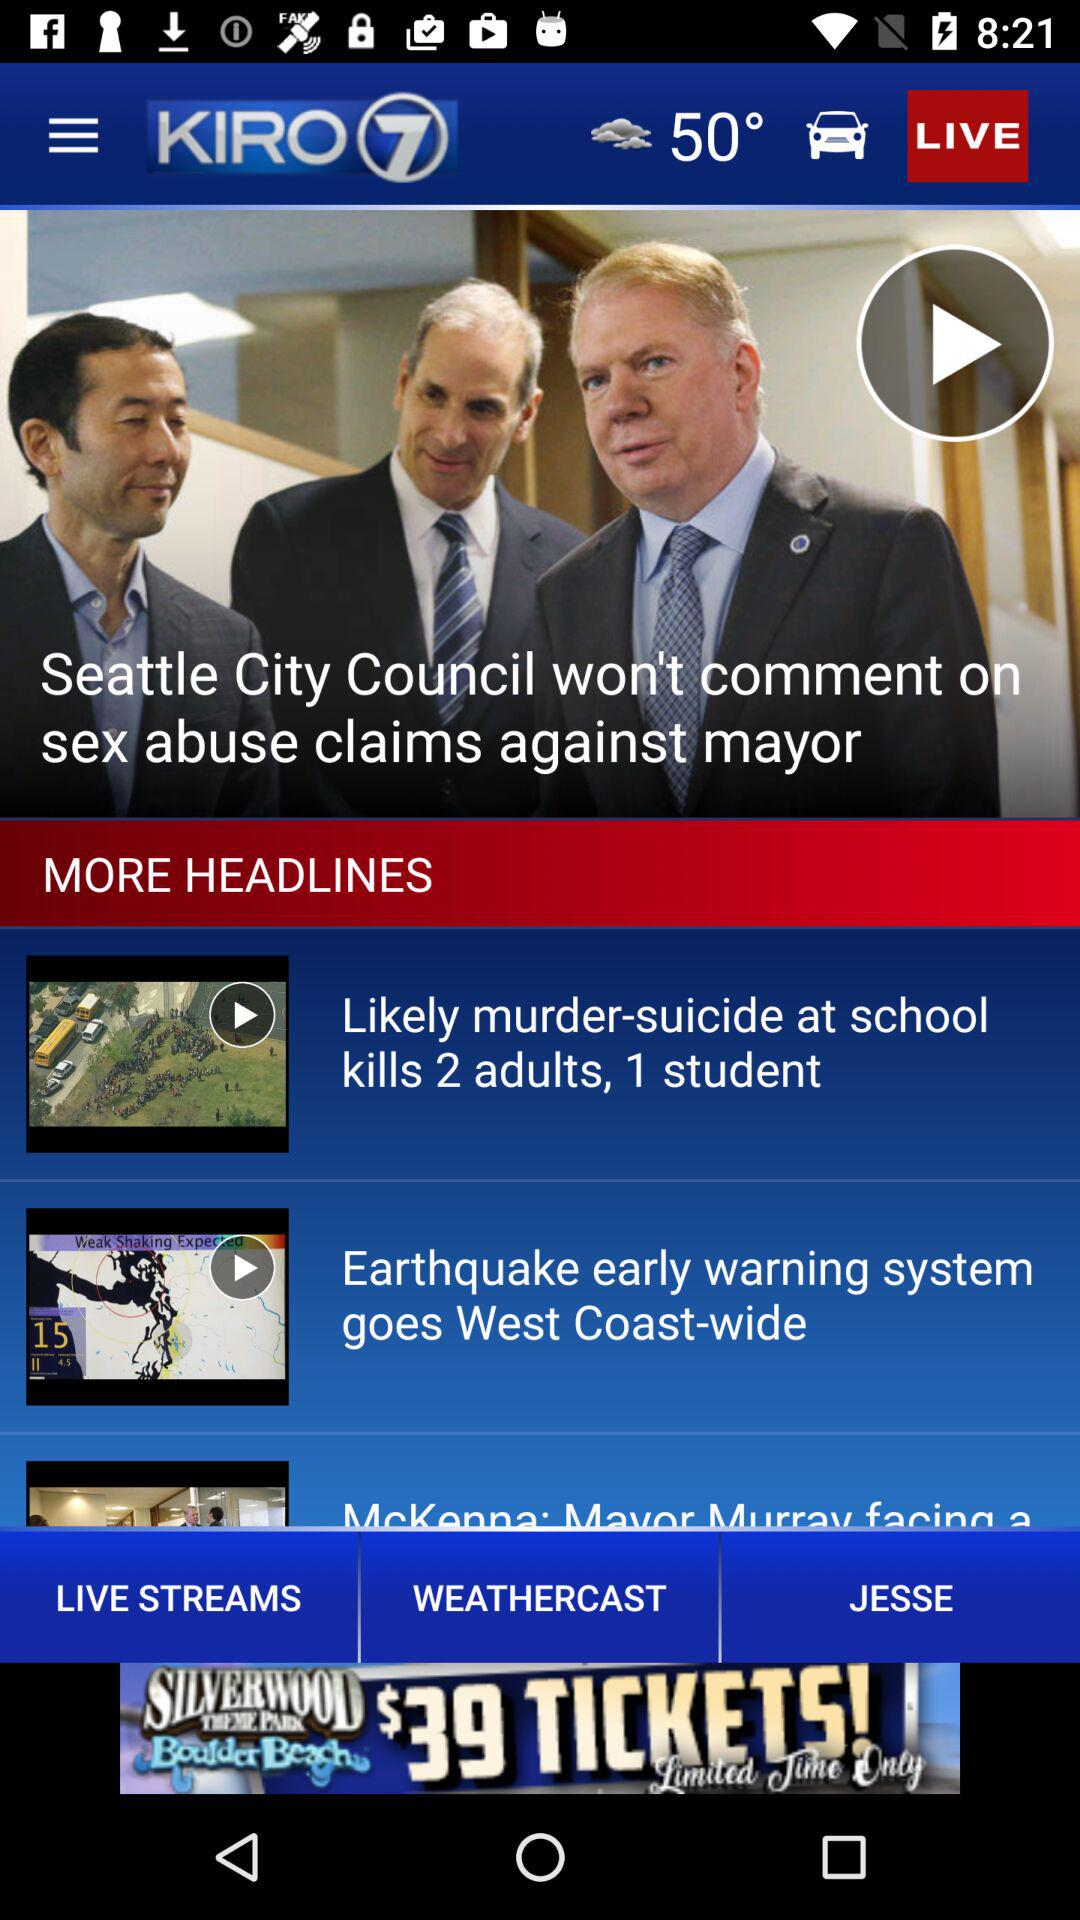What is the temperature? The temperature is 50°. 